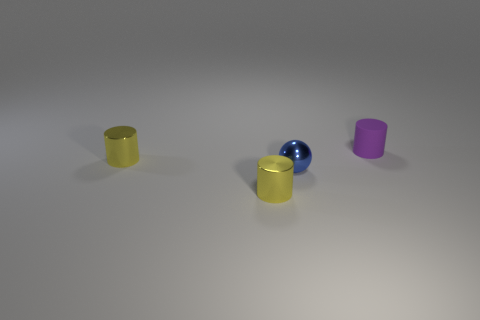Subtract all tiny yellow metallic cylinders. How many cylinders are left? 1 Subtract all yellow cylinders. How many cylinders are left? 1 Add 4 tiny shiny spheres. How many objects exist? 8 Subtract all cylinders. How many objects are left? 1 Subtract all big purple objects. Subtract all blue spheres. How many objects are left? 3 Add 2 yellow metallic cylinders. How many yellow metallic cylinders are left? 4 Add 4 spheres. How many spheres exist? 5 Subtract 0 cyan cylinders. How many objects are left? 4 Subtract all blue cylinders. Subtract all green cubes. How many cylinders are left? 3 Subtract all purple spheres. How many purple cylinders are left? 1 